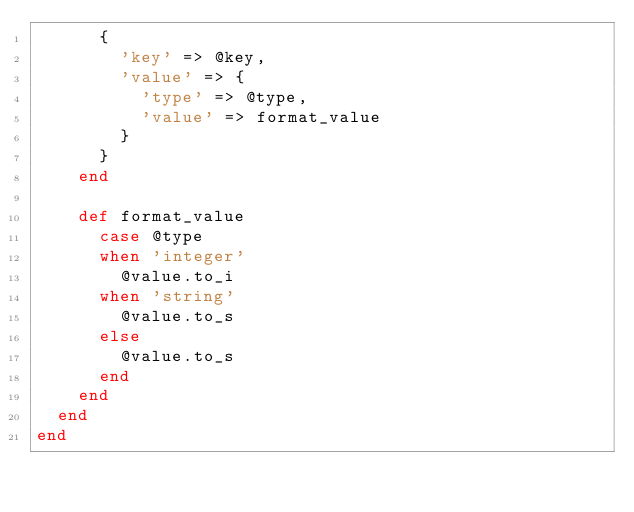Convert code to text. <code><loc_0><loc_0><loc_500><loc_500><_Ruby_>      {
        'key' => @key,
        'value' => {
          'type' => @type,
          'value' => format_value
        }
      }
    end

    def format_value
      case @type
      when 'integer'
        @value.to_i
      when 'string'
        @value.to_s
      else
        @value.to_s
      end
    end
  end
end
</code> 